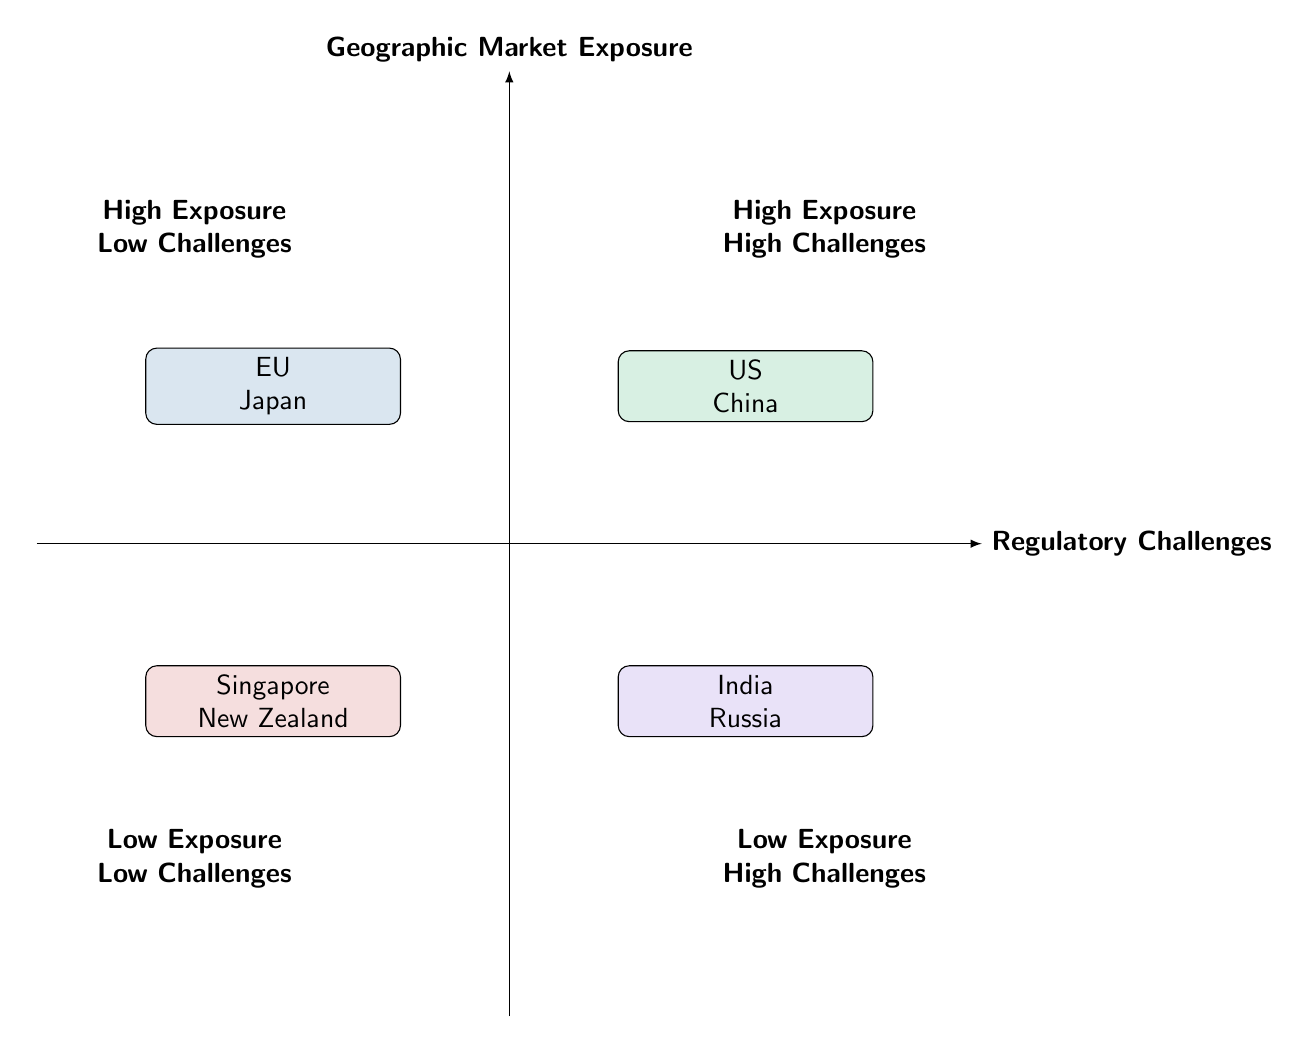What quadrant represents high market exposure and low regulatory challenges? The quadrant in the top-left is labeled as "High Exposure Low Challenges," which indicates that it represents high market exposure with low regulatory challenges.
Answer: High Exposure Low Challenges How many entities are listed in the "High Exposure High Challenges" quadrant? There are two entities mentioned in the "High Exposure High Challenges" quadrant, which are the United States and China.
Answer: 2 What is the regulatory challenge level for Singapore? Singapore is situated in the "Low Exposure Low Challenges" quadrant, indicating that it has low regulatory challenges.
Answer: Low Regulatory Challenges Which two entities are noted for having high market exposure but also face significant regulatory challenges? The "High Exposure High Challenges" quadrant includes the United States and China, where both have considerable market exposure along with high regulatory challenges.
Answer: United States, China Where is New Zealand positioned in terms of market exposure and regulatory challenges? New Zealand is located in the "Low Exposure Low Challenges" quadrant, meaning it has low market exposure and low regulatory challenges according to the diagram.
Answer: Low Exposure Low Challenges Which quadrant includes the entities with both low exposure and high regulatory challenges? The bottom-right quadrant is labeled as "Low Exposure High Challenges," which includes entities that face high regulatory challenges despite their low market exposure.
Answer: Low Exposure High Challenges What example is given for high market exposure but low regulatory challenges? The examples provided for high market exposure with low regulatory challenges are the European Union and Japan.
Answer: European Union, Japan In which quadrant is India located? India is situated in the "Low Exposure High Challenges" quadrant, reflecting its position as an emerging market facing complex regulations despite having low market exposure.
Answer: Low Exposure High Challenges 